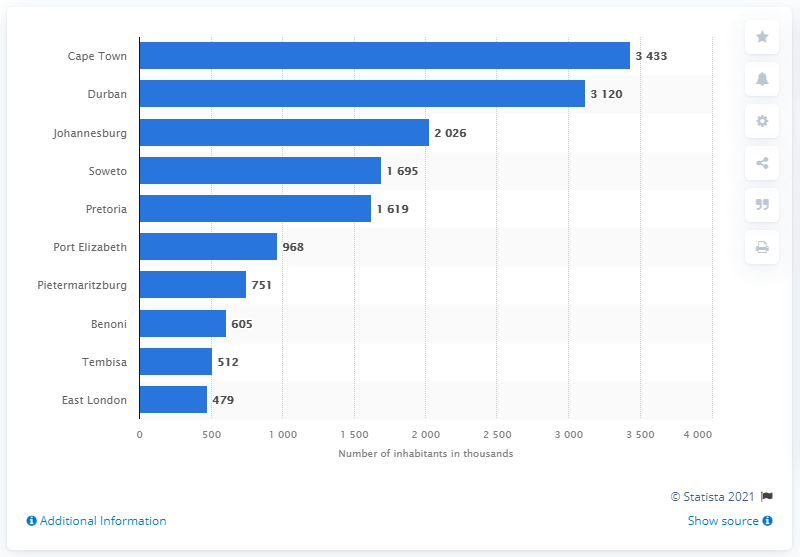List a handful of essential elements in this visual. South Africa's second largest city is Durban. The largest city/municipality of South Africa is Johannesburg. In 2021, Cape Town was the largest city in South Africa. 